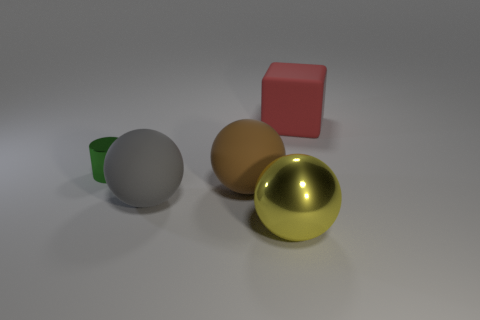What number of green things are the same shape as the big red matte object?
Provide a succinct answer. 0. What is the size of the rubber object that is behind the shiny thing left of the object in front of the gray matte ball?
Your response must be concise. Large. What number of purple objects are small cubes or small cylinders?
Provide a succinct answer. 0. Is the shape of the metallic object in front of the small thing the same as  the big gray rubber thing?
Offer a very short reply. Yes. Are there more big objects that are on the right side of the big gray rubber object than tiny green metal cylinders?
Give a very brief answer. Yes. What number of spheres are the same size as the red matte cube?
Give a very brief answer. 3. How many things are large brown balls or rubber things that are behind the tiny green cylinder?
Ensure brevity in your answer.  2. There is a big thing that is both in front of the large red rubber thing and to the right of the big brown sphere; what is its color?
Keep it short and to the point. Yellow. Does the gray sphere have the same size as the green object?
Ensure brevity in your answer.  No. What is the color of the big matte thing behind the green metallic object?
Ensure brevity in your answer.  Red. 